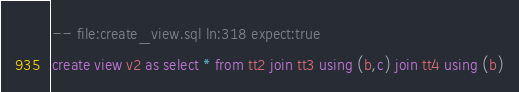<code> <loc_0><loc_0><loc_500><loc_500><_SQL_>-- file:create_view.sql ln:318 expect:true
create view v2 as select * from tt2 join tt3 using (b,c) join tt4 using (b)
</code> 